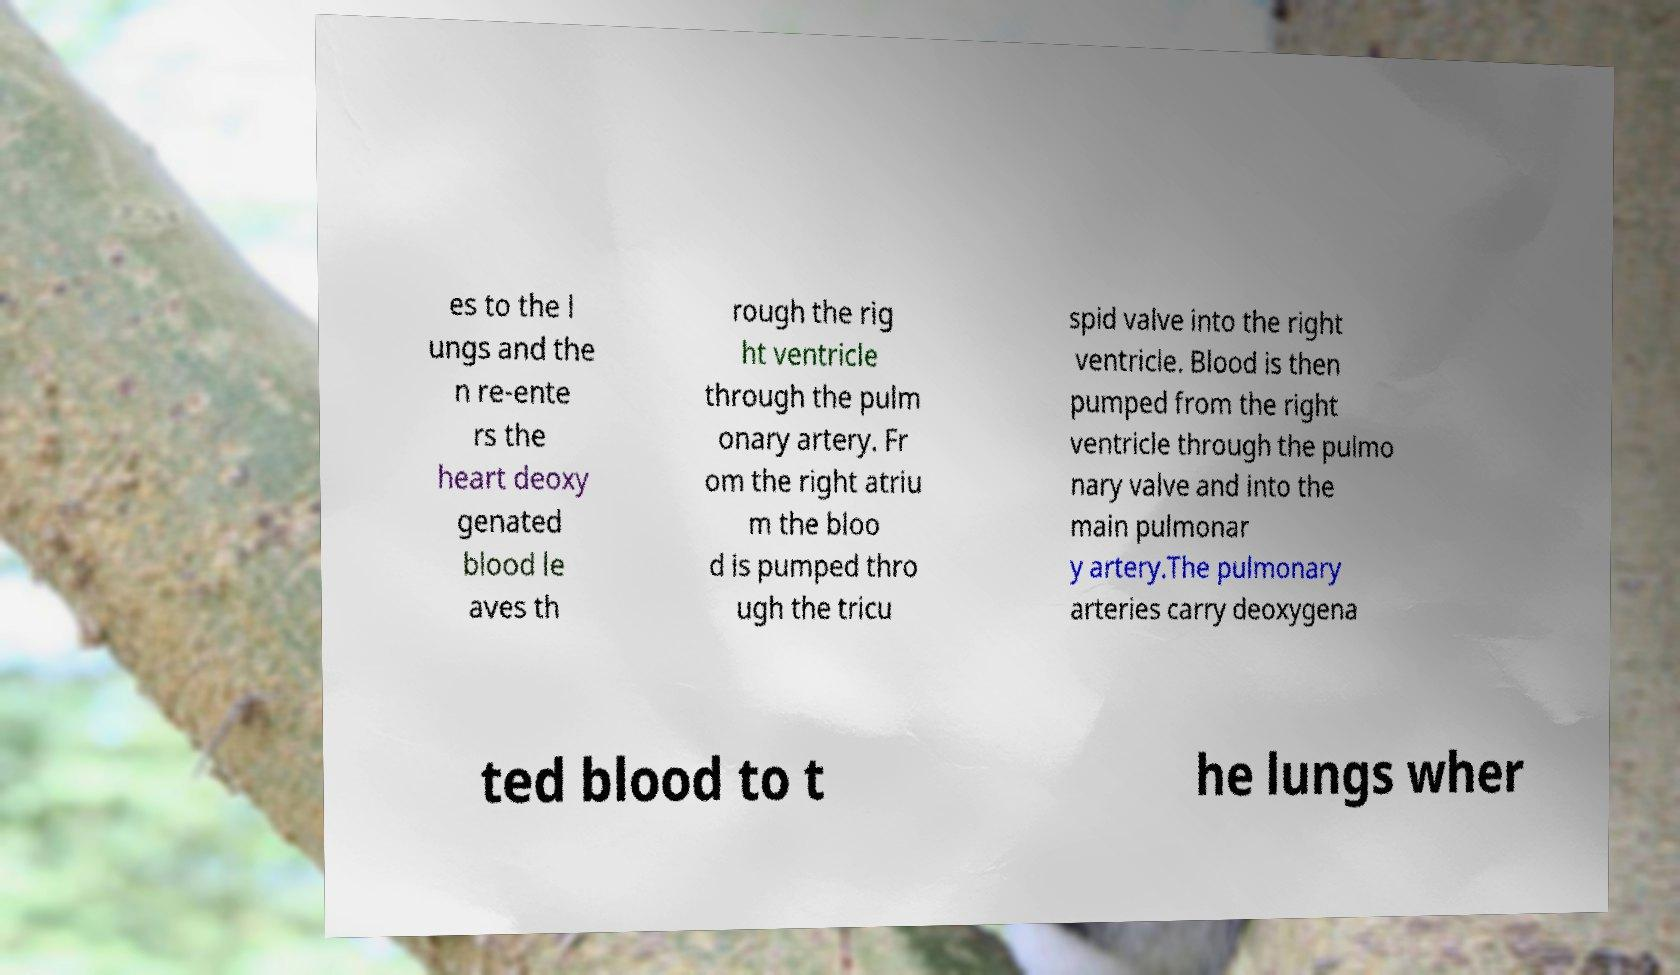Could you extract and type out the text from this image? es to the l ungs and the n re-ente rs the heart deoxy genated blood le aves th rough the rig ht ventricle through the pulm onary artery. Fr om the right atriu m the bloo d is pumped thro ugh the tricu spid valve into the right ventricle. Blood is then pumped from the right ventricle through the pulmo nary valve and into the main pulmonar y artery.The pulmonary arteries carry deoxygena ted blood to t he lungs wher 